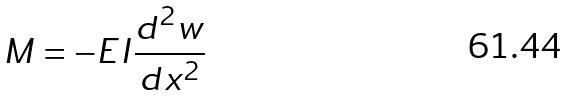<formula> <loc_0><loc_0><loc_500><loc_500>M = - E I \frac { d ^ { 2 } w } { d x ^ { 2 } }</formula> 